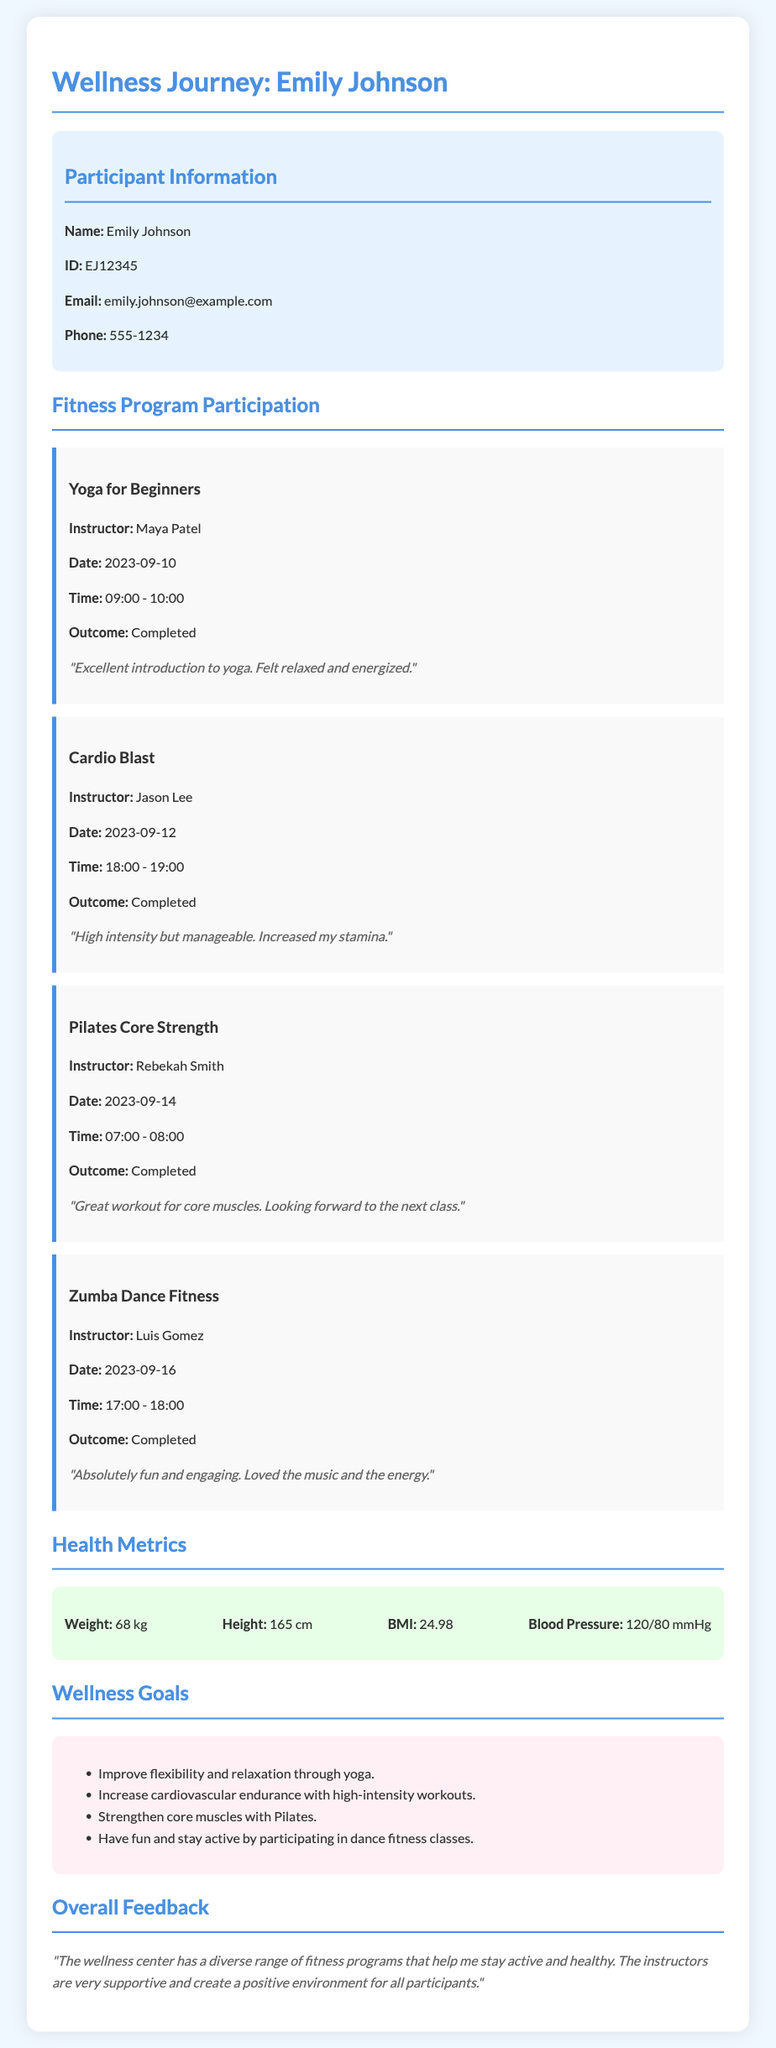What is the name of the participant? The name of the participant is provided in the document.
Answer: Emily Johnson How many fitness programs did Emily participate in? The participation in fitness programs is listed in multiple program cards.
Answer: 4 What is the date of the Yoga for Beginners class? The date is mentioned under the respective program card for Yoga.
Answer: 2023-09-10 Who was the instructor for Zumba Dance Fitness? The document provides the instructor's name for each program.
Answer: Luis Gomez What was Emily's feedback on the Pilates Core Strength class? The feedback for each class is included in the program cards.
Answer: Great workout for core muscles. Looking forward to the next class What is Emily's Blood Pressure reading? The health metrics section lists various health measurements including Blood Pressure.
Answer: 120/80 mmHg What was a goal related to cardiovascular health? A specific wellness goal related to cardiovascular health is listed in the goals section.
Answer: Increase cardiovascular endurance with high-intensity workouts What important outcome did the participant achieve in the Cardio Blast program? The outcome of each program indicates whether it was completed, which can be found in the program card.
Answer: Completed What is the participant's BMI? The BMI is included in the health metrics information available in the document.
Answer: 24.98 